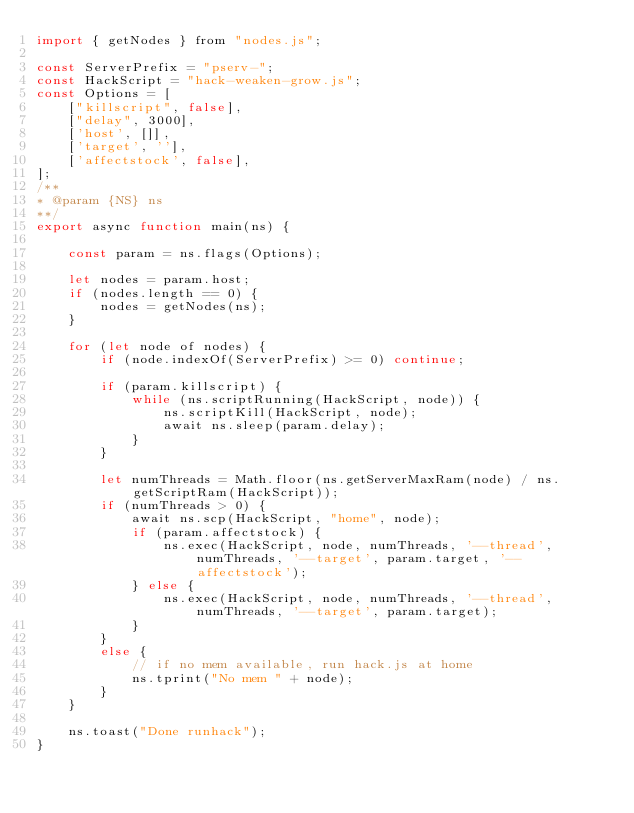<code> <loc_0><loc_0><loc_500><loc_500><_JavaScript_>import { getNodes } from "nodes.js";

const ServerPrefix = "pserv-";
const HackScript = "hack-weaken-grow.js";
const Options = [
    ["killscript", false], 
    ["delay", 3000], 
    ['host', []], 
    ['target', ''],
    ['affectstock', false],
];
/**
* @param {NS} ns
**/
export async function main(ns) {

    const param = ns.flags(Options);

    let nodes = param.host;
    if (nodes.length == 0) {
        nodes = getNodes(ns);
    }

    for (let node of nodes) {
        if (node.indexOf(ServerPrefix) >= 0) continue;

        if (param.killscript) {
            while (ns.scriptRunning(HackScript, node)) {
                ns.scriptKill(HackScript, node);
                await ns.sleep(param.delay);
            }
        }

        let numThreads = Math.floor(ns.getServerMaxRam(node) / ns.getScriptRam(HackScript));
        if (numThreads > 0) {
            await ns.scp(HackScript, "home", node);
            if (param.affectstock) {
                ns.exec(HackScript, node, numThreads, '--thread', numThreads, '--target', param.target, '--affectstock');
            } else {
                ns.exec(HackScript, node, numThreads, '--thread', numThreads, '--target', param.target);
            }
        }
        else {
            // if no mem available, run hack.js at home
            ns.tprint("No mem " + node);
        }
    }

    ns.toast("Done runhack");
}

</code> 